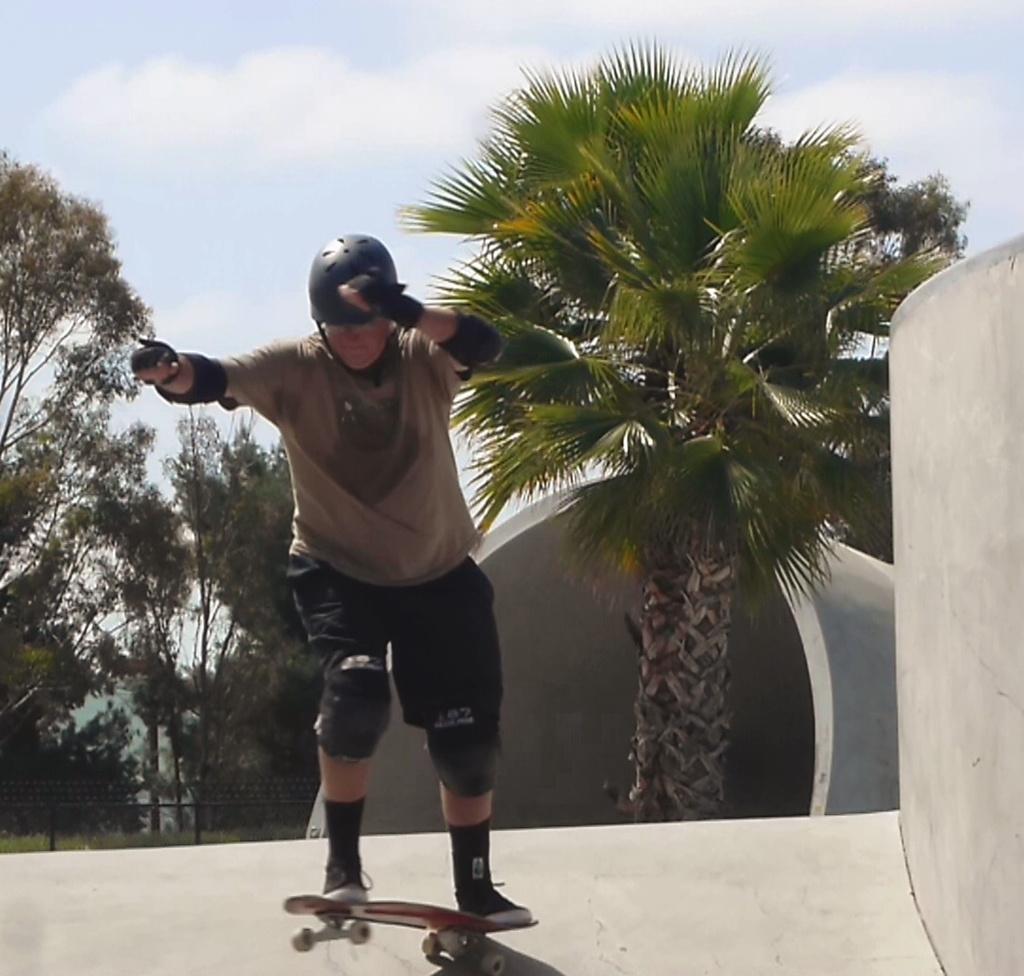Could you give a brief overview of what you see in this image? In this image there is a person skating on the platform with a skateboard, behind the person there are trees, beside the person there is a wall and behind the person there is a cylindrical shaped concrete structure, at the top of the image there are clouds in the sky. 